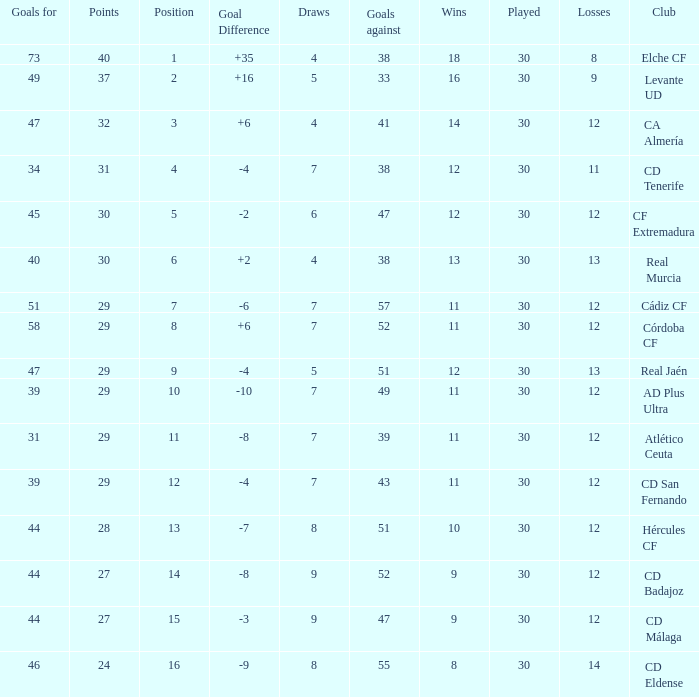What is the sum of the goals with less than 30 points, a position less than 10, and more than 57 goals against? None. 